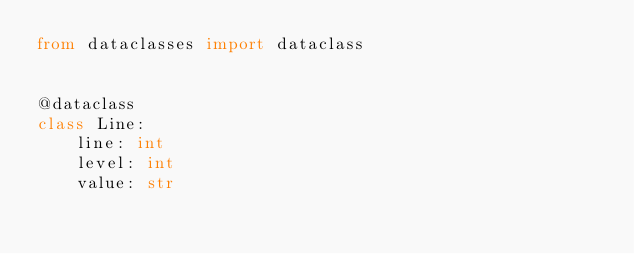Convert code to text. <code><loc_0><loc_0><loc_500><loc_500><_Python_>from dataclasses import dataclass


@dataclass
class Line:
    line: int
    level: int
    value: str
</code> 